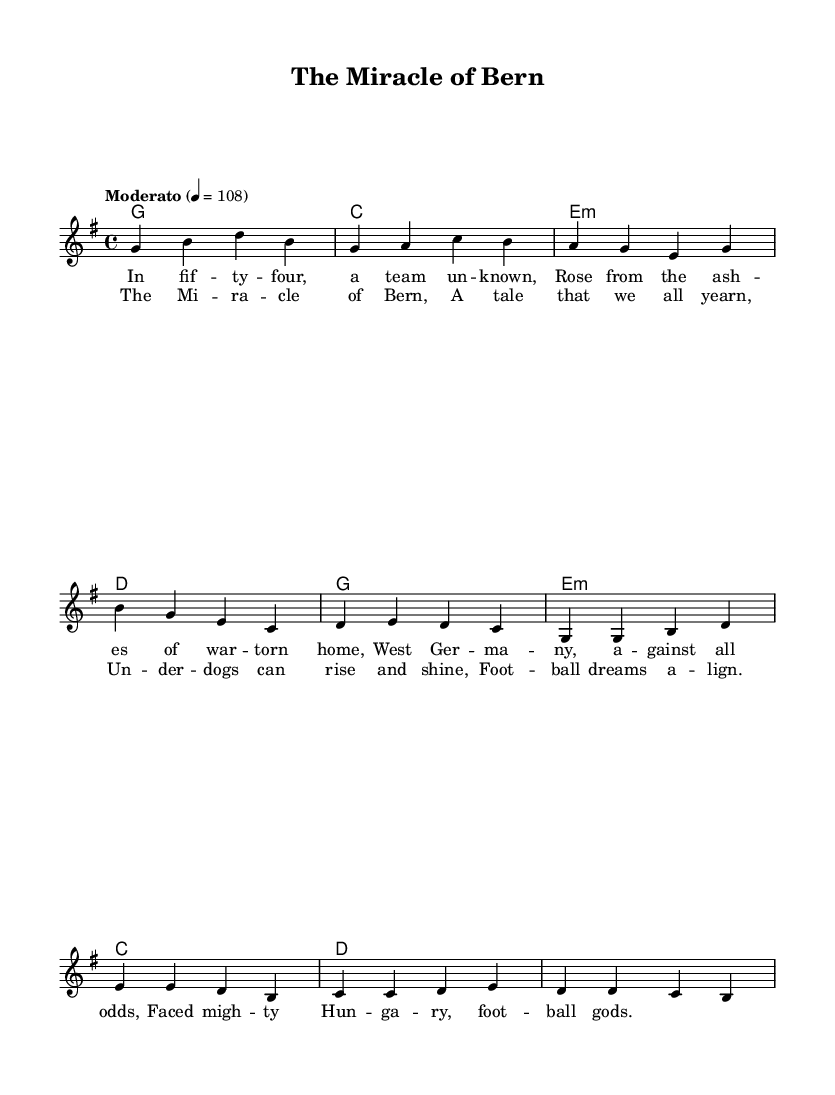What is the key signature of this music? The key signature is indicated at the beginning of the staff, showing a G major scale which has one sharp (F#).
Answer: G major What is the time signature of this music? The time signature is represented at the beginning of the piece, where the 4/4 indicates four beats per measure.
Answer: 4/4 What is the tempo marking of this music? The tempo is located in the header section, which states "Moderato" along with the metronome marking of 108 beats per minute.
Answer: Moderato How many measures are in the verse section? The verse consists of a series of musical phrases written in measures; by counting the measures in the verse section specifically, it totals to 5 measures.
Answer: 5 What type of chords are used in the chorus? The chorus section includes a set of chords that are generally used in folk music; the chords listed are G, E minor, C, and D, which are common in folk anthems.
Answer: G, E minor, C, D What story does the lyrics of the song convey? The lyrics provide a narrative about the underdog story of West Germany's football team in the 1954 World Cup, emphasizing resilience against stronger opponents.
Answer: Under dog story What instrument is the lead vocal score intended for? The lead vocal score is notated on the staff with musical notes, it is typically intended for voice performance, likely meant to be sung.
Answer: Voice 